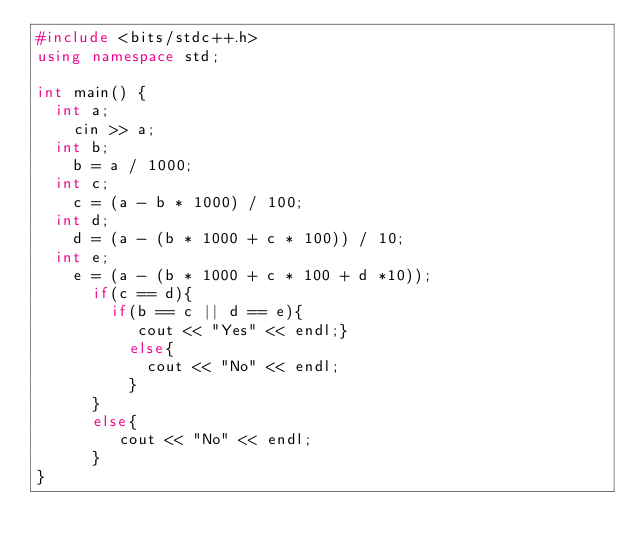Convert code to text. <code><loc_0><loc_0><loc_500><loc_500><_C++_>#include <bits/stdc++.h>
using namespace std;

int main() {
  int a;
  	cin >> a;
  int b;
  	b = a / 1000;
  int c;
  	c = (a - b * 1000) / 100;
  int d;
  	d = (a - (b * 1000 + c * 100)) / 10;
  int e;
    e = (a - (b * 1000 + c * 100 + d *10));
      if(c == d){
        if(b == c || d == e){
           cout << "Yes" << endl;}
          else{
            cout << "No" << endl;
          }
      }
  	  else{
         cout << "No" << endl;
      }
}</code> 